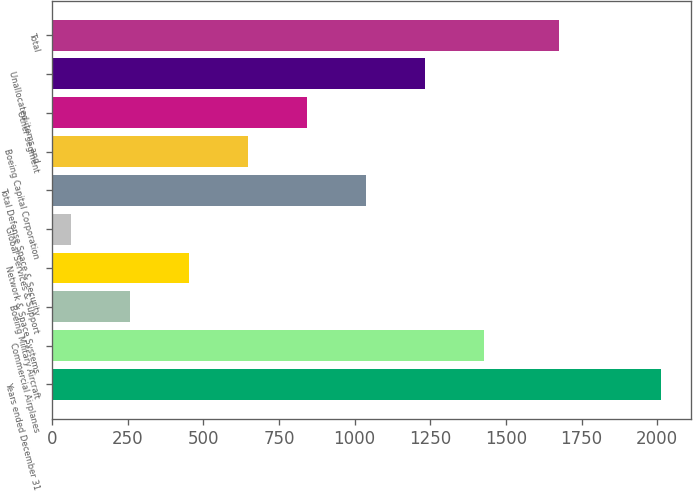Convert chart to OTSL. <chart><loc_0><loc_0><loc_500><loc_500><bar_chart><fcel>Years ended December 31<fcel>Commercial Airplanes<fcel>Boeing Military Aircraft<fcel>Network & Space Systems<fcel>Global Services & Support<fcel>Total Defense Space & Security<fcel>Boeing Capital Corporation<fcel>Other segment<fcel>Unallocated items and<fcel>Total<nl><fcel>2011<fcel>1426.3<fcel>256.9<fcel>451.8<fcel>62<fcel>1036.5<fcel>646.7<fcel>841.6<fcel>1231.4<fcel>1675<nl></chart> 